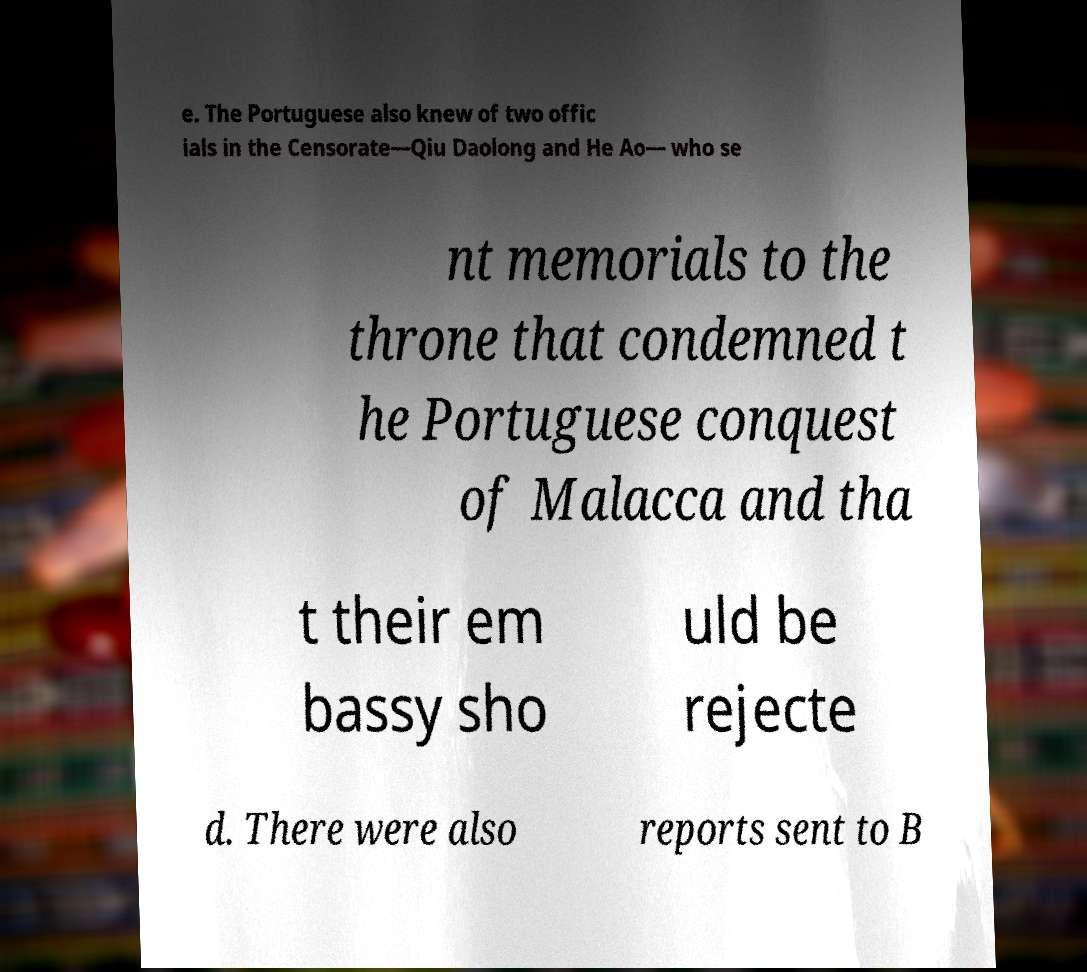What messages or text are displayed in this image? I need them in a readable, typed format. e. The Portuguese also knew of two offic ials in the Censorate—Qiu Daolong and He Ao— who se nt memorials to the throne that condemned t he Portuguese conquest of Malacca and tha t their em bassy sho uld be rejecte d. There were also reports sent to B 